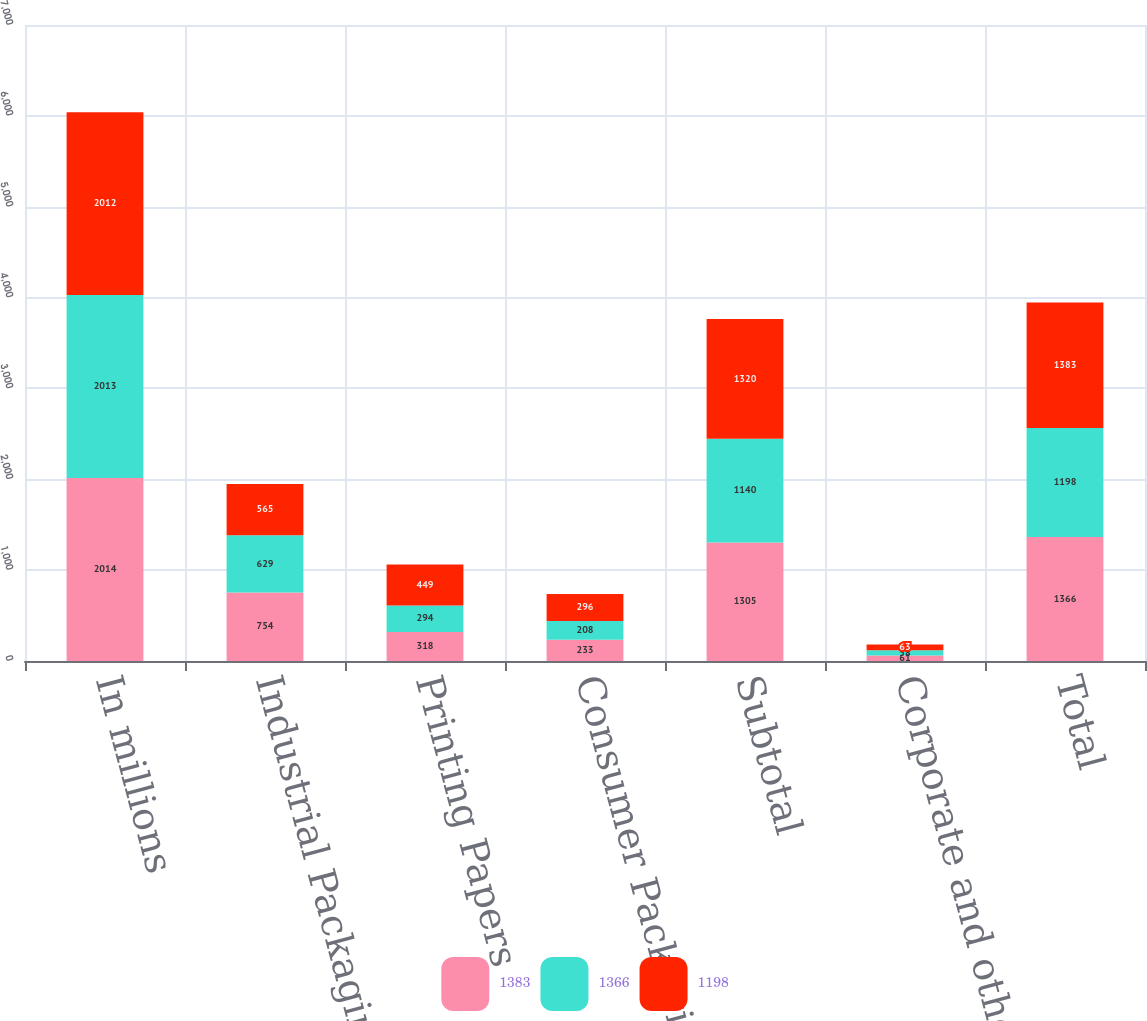Convert chart. <chart><loc_0><loc_0><loc_500><loc_500><stacked_bar_chart><ecel><fcel>In millions<fcel>Industrial Packaging<fcel>Printing Papers<fcel>Consumer Packaging<fcel>Subtotal<fcel>Corporate and other (c)<fcel>Total<nl><fcel>1383<fcel>2014<fcel>754<fcel>318<fcel>233<fcel>1305<fcel>61<fcel>1366<nl><fcel>1366<fcel>2013<fcel>629<fcel>294<fcel>208<fcel>1140<fcel>58<fcel>1198<nl><fcel>1198<fcel>2012<fcel>565<fcel>449<fcel>296<fcel>1320<fcel>63<fcel>1383<nl></chart> 